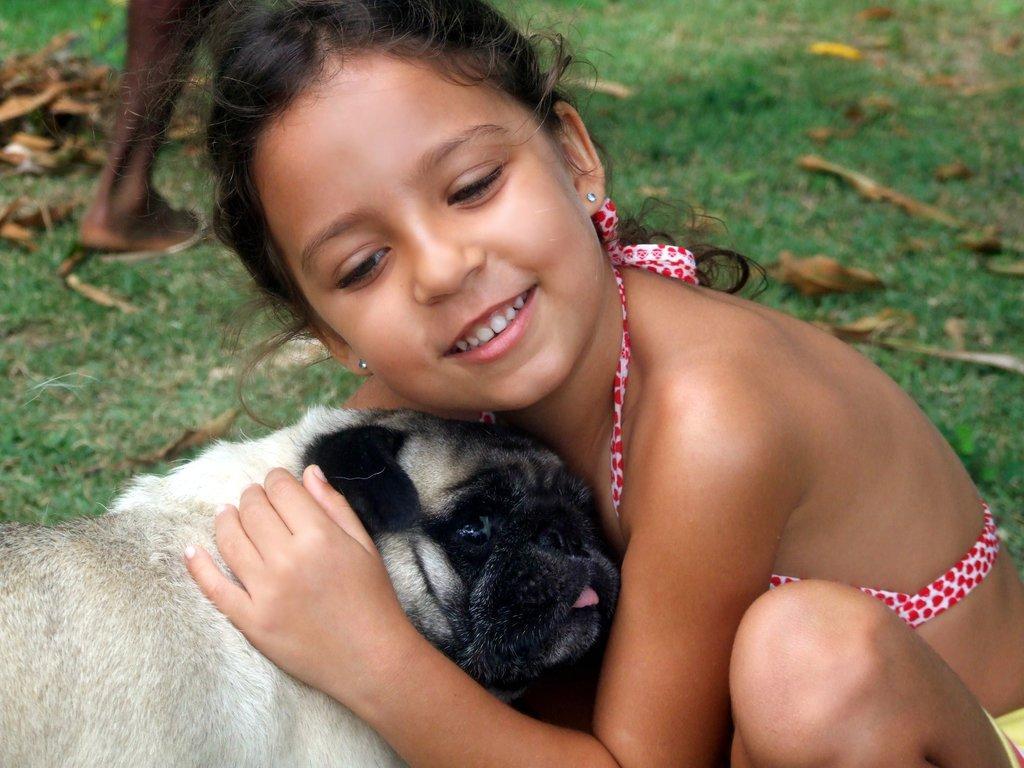Describe this image in one or two sentences. In this image I can see a girl and a dog in the front. There is grass, there are dry leaves on it and there are legs of a person, at the back. 